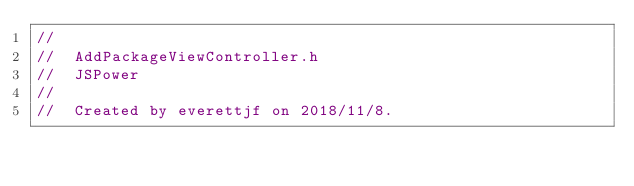Convert code to text. <code><loc_0><loc_0><loc_500><loc_500><_C_>//
//  AddPackageViewController.h
//  JSPower
//
//  Created by everettjf on 2018/11/8.</code> 